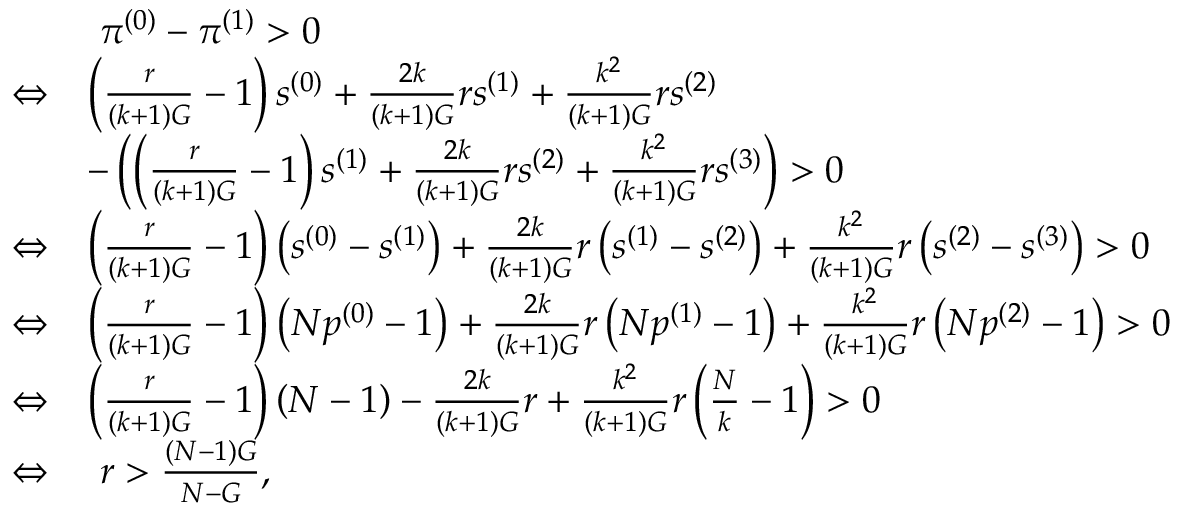<formula> <loc_0><loc_0><loc_500><loc_500>\begin{array} { r l } & { \pi ^ { ( 0 ) } - \pi ^ { ( 1 ) } > 0 } \\ { \Leftrightarrow } & { \left ( \frac { r } { ( k + 1 ) G } - 1 \right ) s ^ { ( 0 ) } + \frac { 2 k } { ( k + 1 ) G } r s ^ { ( 1 ) } + \frac { k ^ { 2 } } { ( k + 1 ) G } r s ^ { ( 2 ) } } \\ & { - \left ( \left ( \frac { r } { ( k + 1 ) G } - 1 \right ) s ^ { ( 1 ) } + \frac { 2 k } { ( k + 1 ) G } r s ^ { ( 2 ) } + \frac { k ^ { 2 } } { ( k + 1 ) G } r s ^ { ( 3 ) } \right ) > 0 } \\ { \Leftrightarrow } & { \left ( \frac { r } { ( k + 1 ) G } - 1 \right ) \left ( s ^ { ( 0 ) } - s ^ { ( 1 ) } \right ) + \frac { 2 k } { ( k + 1 ) G } r \left ( s ^ { ( 1 ) } - s ^ { ( 2 ) } \right ) + \frac { k ^ { 2 } } { ( k + 1 ) G } r \left ( s ^ { ( 2 ) } - s ^ { ( 3 ) } \right ) > 0 } \\ { \Leftrightarrow } & { \left ( \frac { r } { ( k + 1 ) G } - 1 \right ) \left ( N p ^ { ( 0 ) } - 1 \right ) + \frac { 2 k } { ( k + 1 ) G } r \left ( N p ^ { ( 1 ) } - 1 \right ) + \frac { k ^ { 2 } } { ( k + 1 ) G } r \left ( N p ^ { ( 2 ) } - 1 \right ) > 0 } \\ { \Leftrightarrow } & { \left ( \frac { r } { ( k + 1 ) G } - 1 \right ) \left ( N - 1 \right ) - \frac { 2 k } { ( k + 1 ) G } r + \frac { k ^ { 2 } } { ( k + 1 ) G } r \left ( \frac { N } { k } - 1 \right ) > 0 } \\ { \Leftrightarrow } & { r > \frac { ( N - 1 ) G } { N - G } , } \end{array}</formula> 